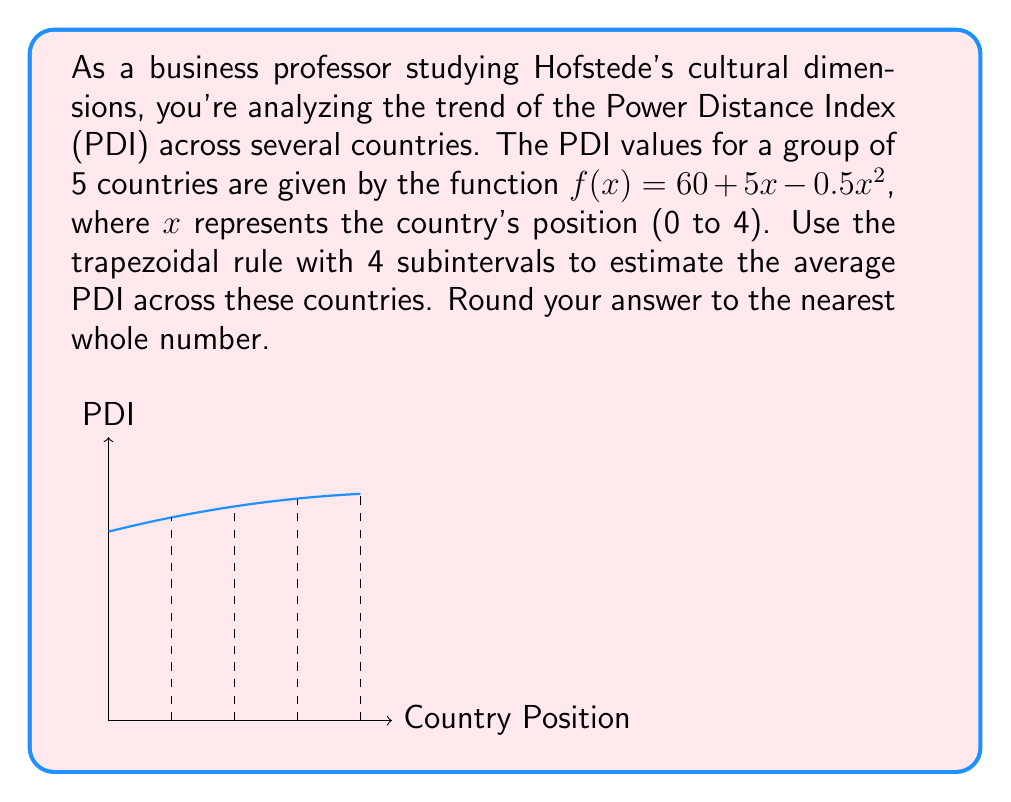Can you solve this math problem? Let's approach this step-by-step using the trapezoidal rule:

1) The trapezoidal rule for n subintervals is given by:

   $$\int_{a}^{b} f(x) dx \approx \frac{h}{2}[f(x_0) + 2f(x_1) + 2f(x_2) + ... + 2f(x_{n-1}) + f(x_n)]$$

   where $h = \frac{b-a}{n}$

2) In our case, $a=0$, $b=4$, and $n=4$. So, $h = \frac{4-0}{4} = 1$

3) We need to calculate $f(x)$ for $x = 0, 1, 2, 3, 4$:

   $f(0) = 60 + 5(0) - 0.5(0)^2 = 60$
   $f(1) = 60 + 5(1) - 0.5(1)^2 = 64.5$
   $f(2) = 60 + 5(2) - 0.5(2)^2 = 67$
   $f(3) = 60 + 5(3) - 0.5(3)^2 = 67.5$
   $f(4) = 60 + 5(4) - 0.5(4)^2 = 66$

4) Applying the trapezoidal rule:

   $$\int_{0}^{4} f(x) dx \approx \frac{1}{2}[60 + 2(64.5) + 2(67) + 2(67.5) + 66]$$
   
   $$= \frac{1}{2}[60 + 129 + 134 + 135 + 66] = \frac{524}{2} = 262$$

5) To find the average, we divide by the interval width:

   Average PDI $= \frac{262}{4} = 65.5$

6) Rounding to the nearest whole number: 66
Answer: 66 